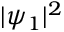Convert formula to latex. <formula><loc_0><loc_0><loc_500><loc_500>| \psi _ { 1 } | ^ { 2 }</formula> 